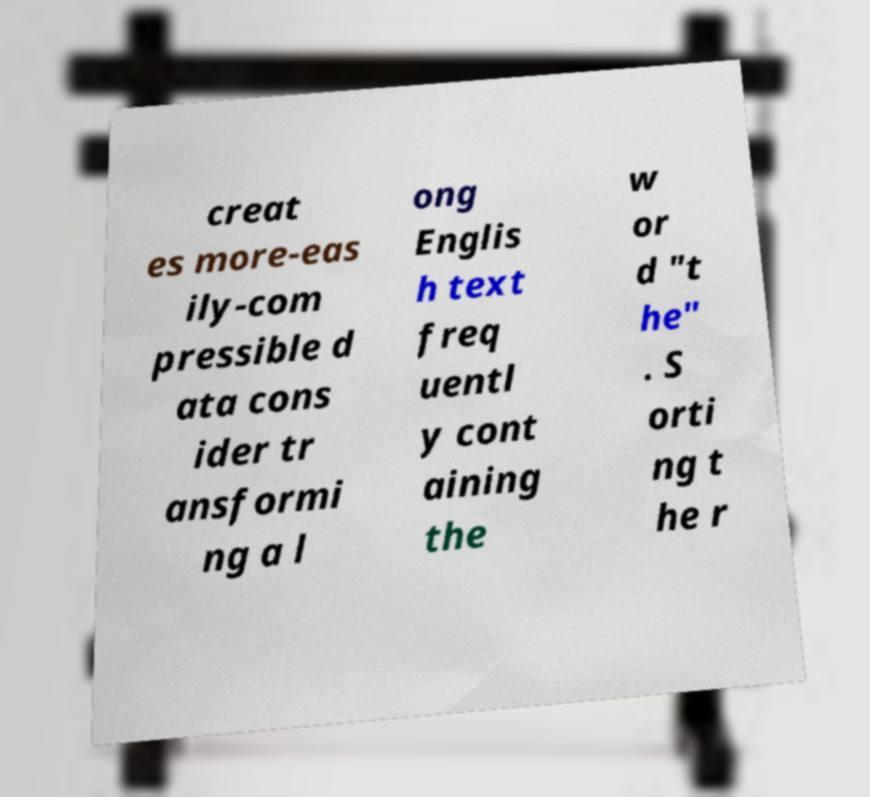Can you accurately transcribe the text from the provided image for me? creat es more-eas ily-com pressible d ata cons ider tr ansformi ng a l ong Englis h text freq uentl y cont aining the w or d "t he" . S orti ng t he r 